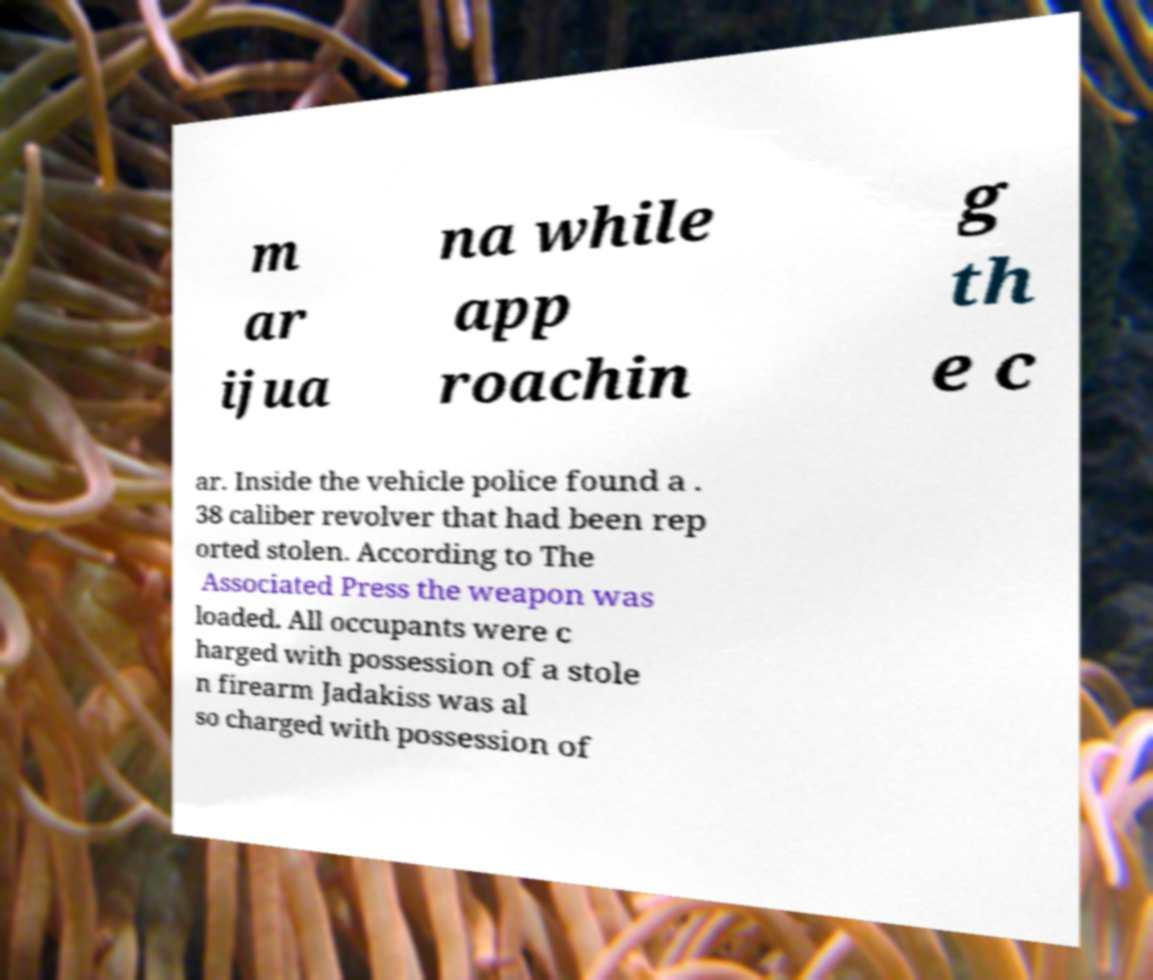There's text embedded in this image that I need extracted. Can you transcribe it verbatim? m ar ijua na while app roachin g th e c ar. Inside the vehicle police found a . 38 caliber revolver that had been rep orted stolen. According to The Associated Press the weapon was loaded. All occupants were c harged with possession of a stole n firearm Jadakiss was al so charged with possession of 